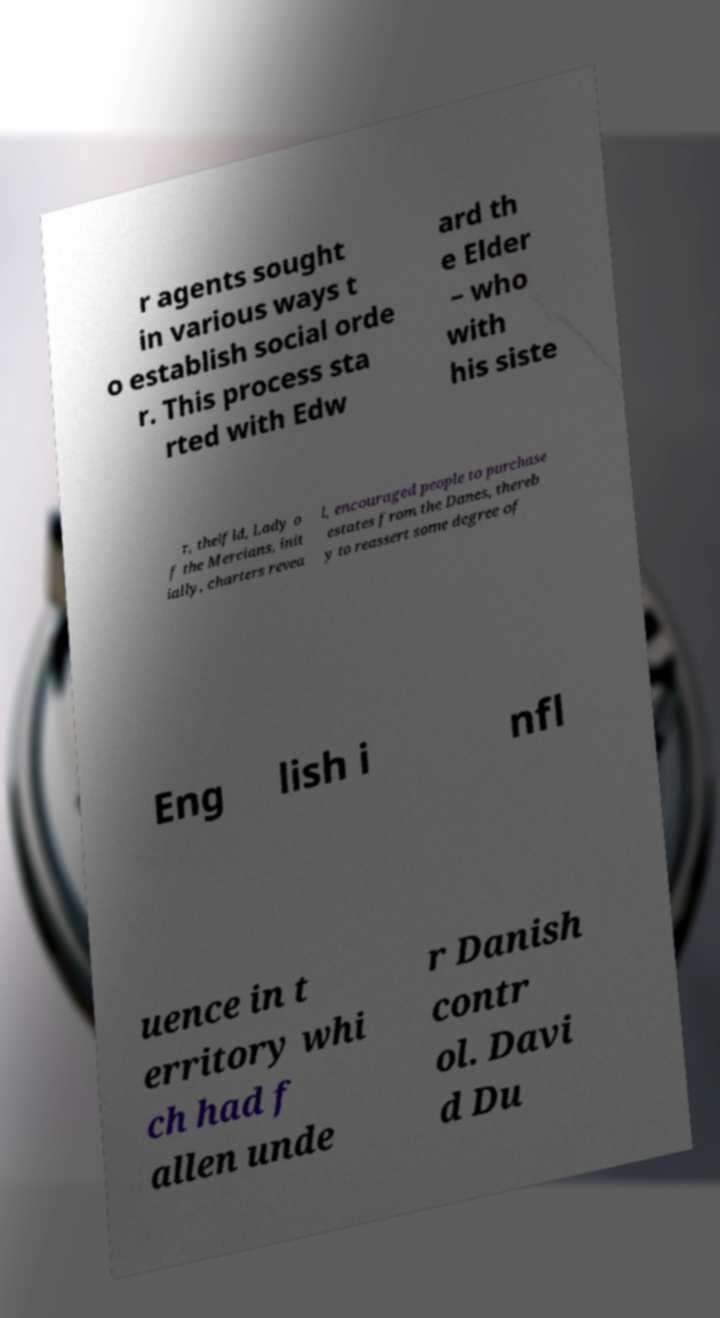Could you assist in decoding the text presented in this image and type it out clearly? r agents sought in various ways t o establish social orde r. This process sta rted with Edw ard th e Elder – who with his siste r, thelfld, Lady o f the Mercians, init ially, charters revea l, encouraged people to purchase estates from the Danes, thereb y to reassert some degree of Eng lish i nfl uence in t erritory whi ch had f allen unde r Danish contr ol. Davi d Du 